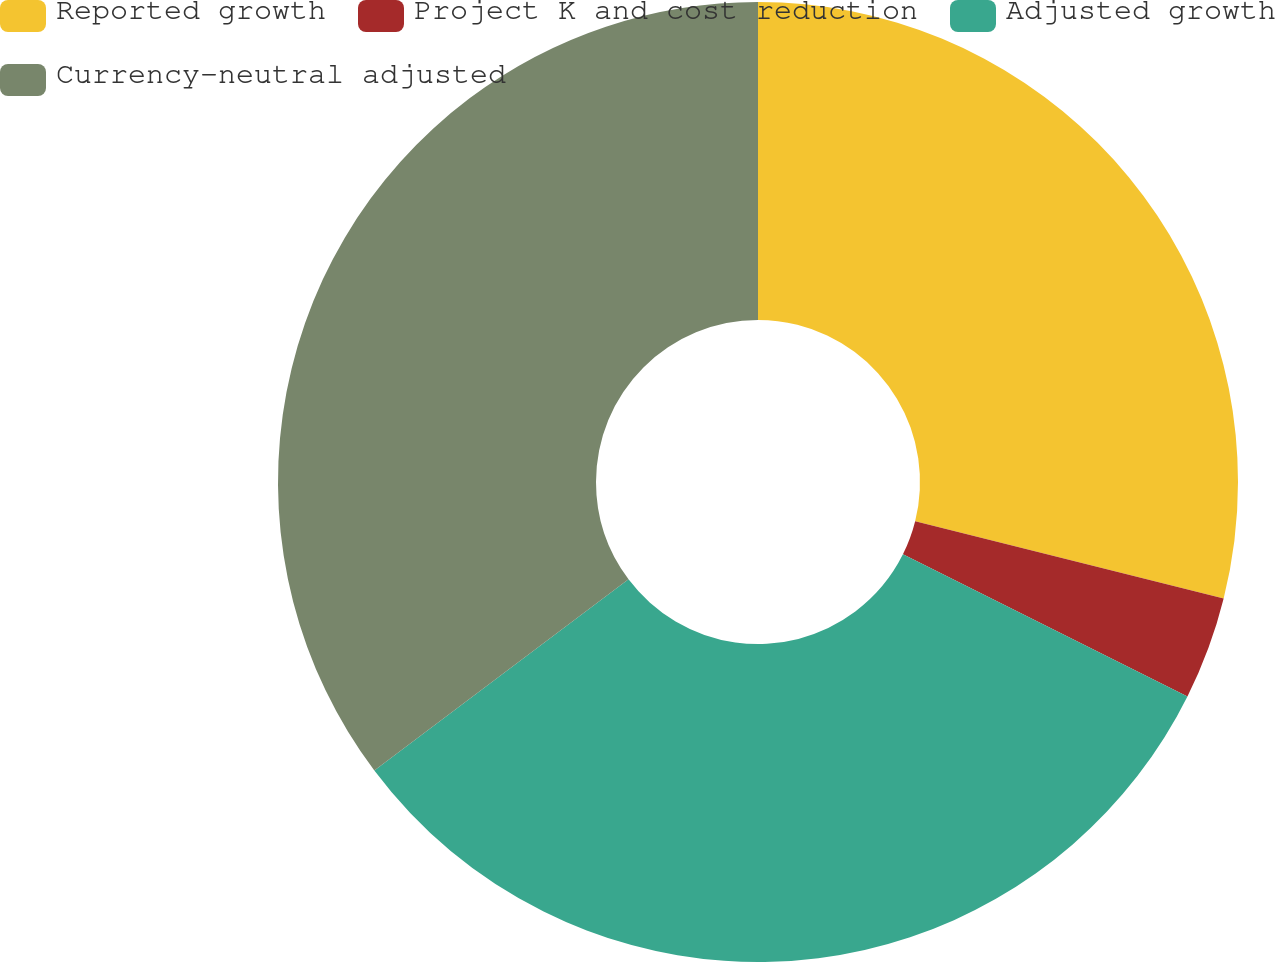<chart> <loc_0><loc_0><loc_500><loc_500><pie_chart><fcel>Reported growth<fcel>Project K and cost reduction<fcel>Adjusted growth<fcel>Currency-neutral adjusted<nl><fcel>28.9%<fcel>3.47%<fcel>32.37%<fcel>35.26%<nl></chart> 